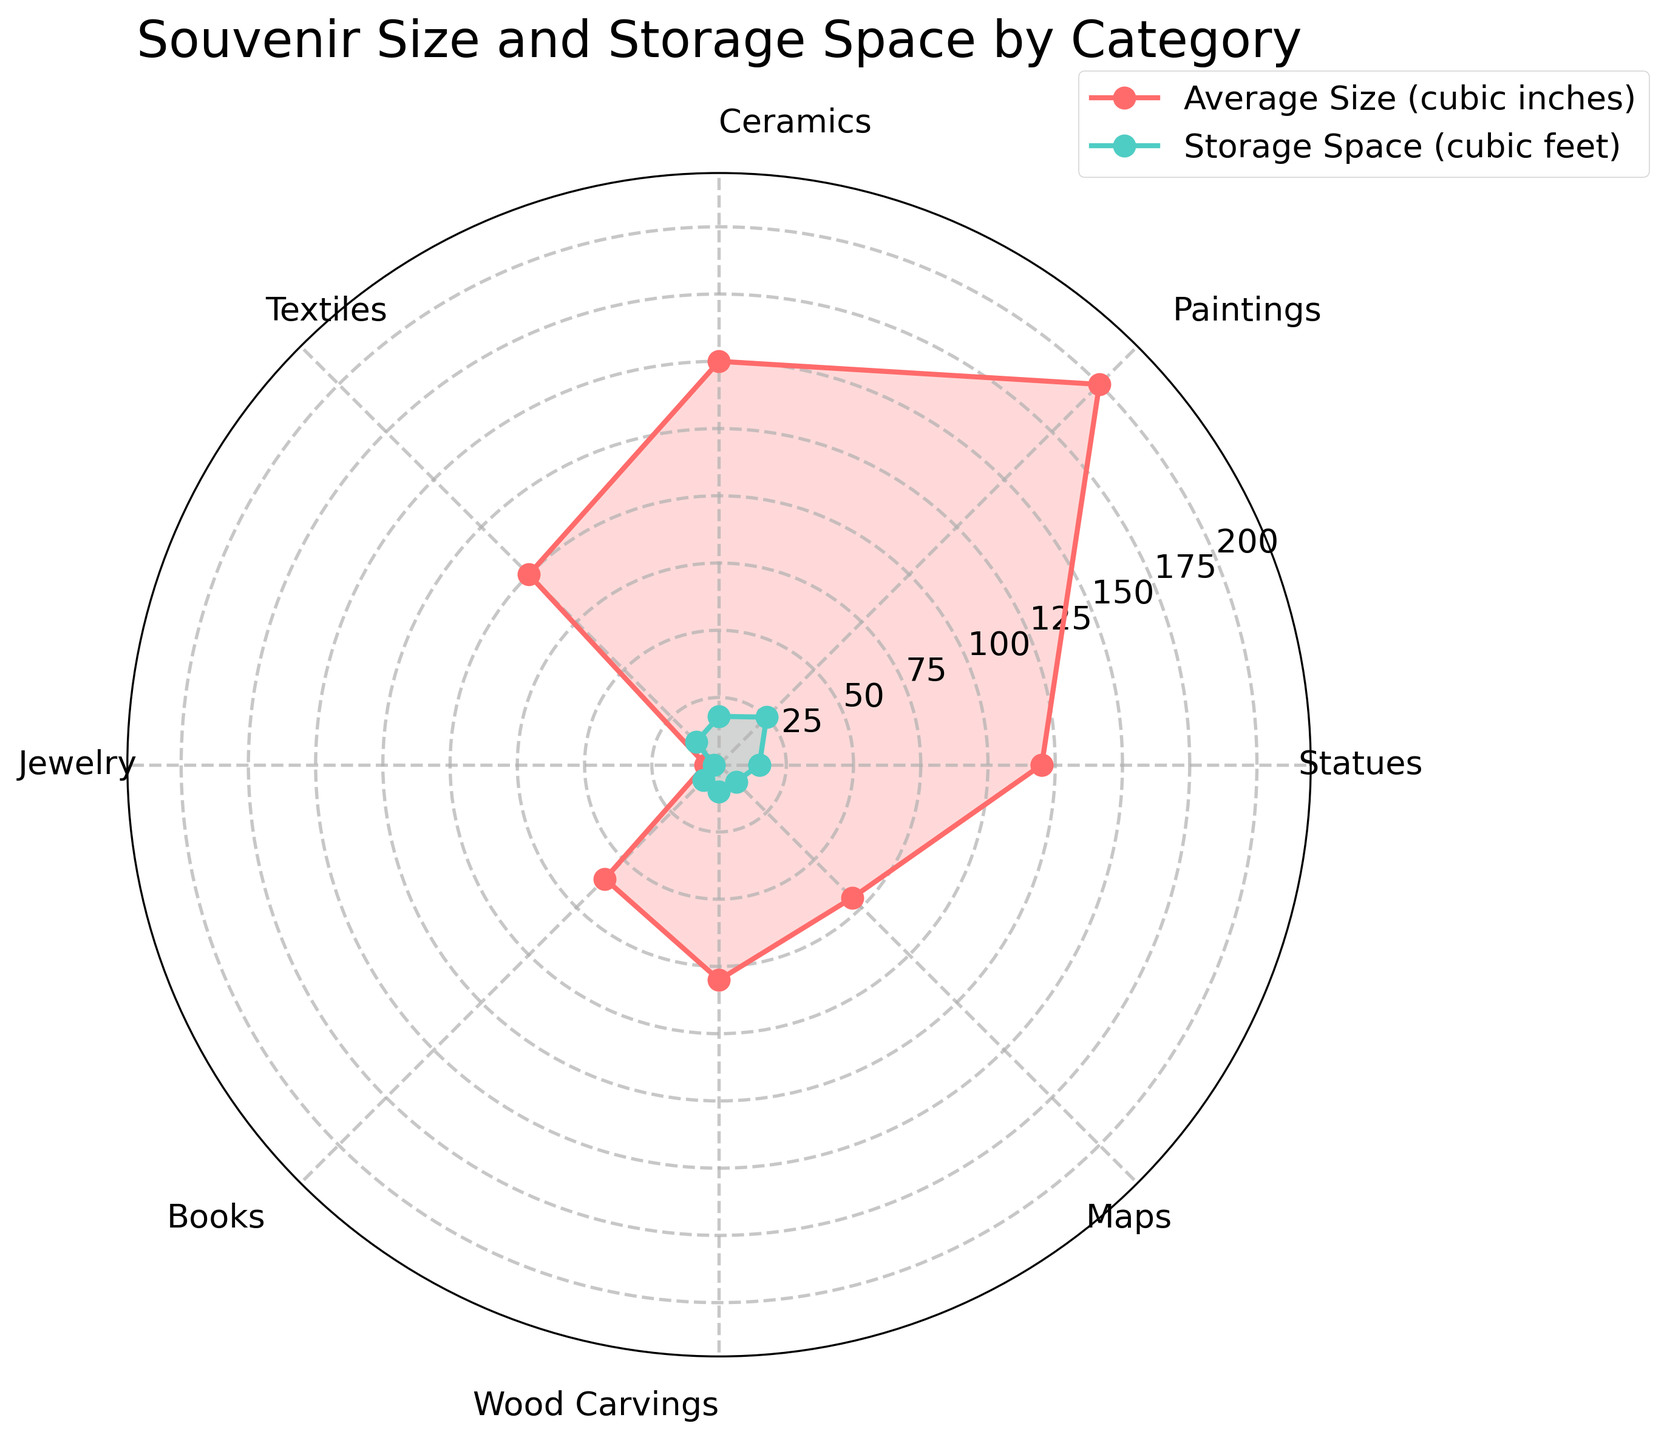what's the title of the radar chart? The title is located at the top center of the figure. It indicates the subject of the data being visualized. The title can be directly read from the chart.
Answer: Souvenir Size and Storage Space by Category what is the range of the y-axis in the radar chart? The range of the y-axis represents the minimum to maximum value of the data in the chart. It can be determined by the scale shown along the radial lines of the radar chart.
Answer: 0 to around 275 which category has the smallest average size? By looking at the points on the radar chart, the category with the point closest to the center for "Average Size (cubic inches)" indicates the smallest value.
Answer: Jewelry How does the storage space required for Textiles compare to Wood Carvings? By comparing the lengths of the radial lines for "Storage Space (cubic feet)" for Textiles and Wood Carvings, the category that has the longer line requires more storage space.
Answer: Textiles require more storage space than Wood Carvings what category has the largest storage space requirement? The category with the point farthest from the center on the radar chart for "Storage Space (cubic feet)" indicates the highest value.
Answer: Paintings which two categories have storage space requirements that are closest to each other? By visually comparing the lengths of the lines for "Storage Space (cubic feet)" in the radar chart, we can identify the two categories with the most similar line lengths.
Answer: Maps and Wood Carvings what's the difference in average size between Paintings and Books? The average size values for each category are noted on the chart, and the difference is calculated by subtracting the value for Books from that for Paintings.
Answer: 140 cubic inches Is there any category where the average size corresponds almost equally with its storage space requirement? By comparing the two different colored lines (one for average size and one for storage space) in the radar chart, identify the category where the radial lengths are nearly equal.
Answer: Books which category has the highest ratio of storage space to average size? Calculate the ratio (storage space / average size) for each category and then identify the one with the highest ratio from the chart values.
Answer: Jewelry which category requires the most storage space relative to its average size? Calculate the storage space per cubic inch of the average size for each category, then identify the one with the highest value from the chart.
Answer: Jewelry 